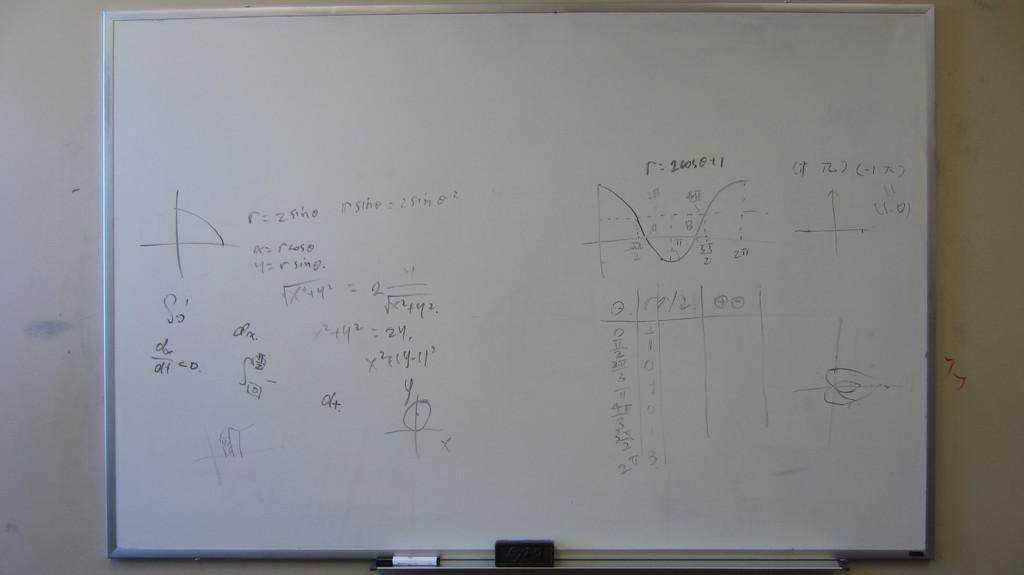<image>
Write a terse but informative summary of the picture. White board that shows an equation and the answer for the letter "r". 